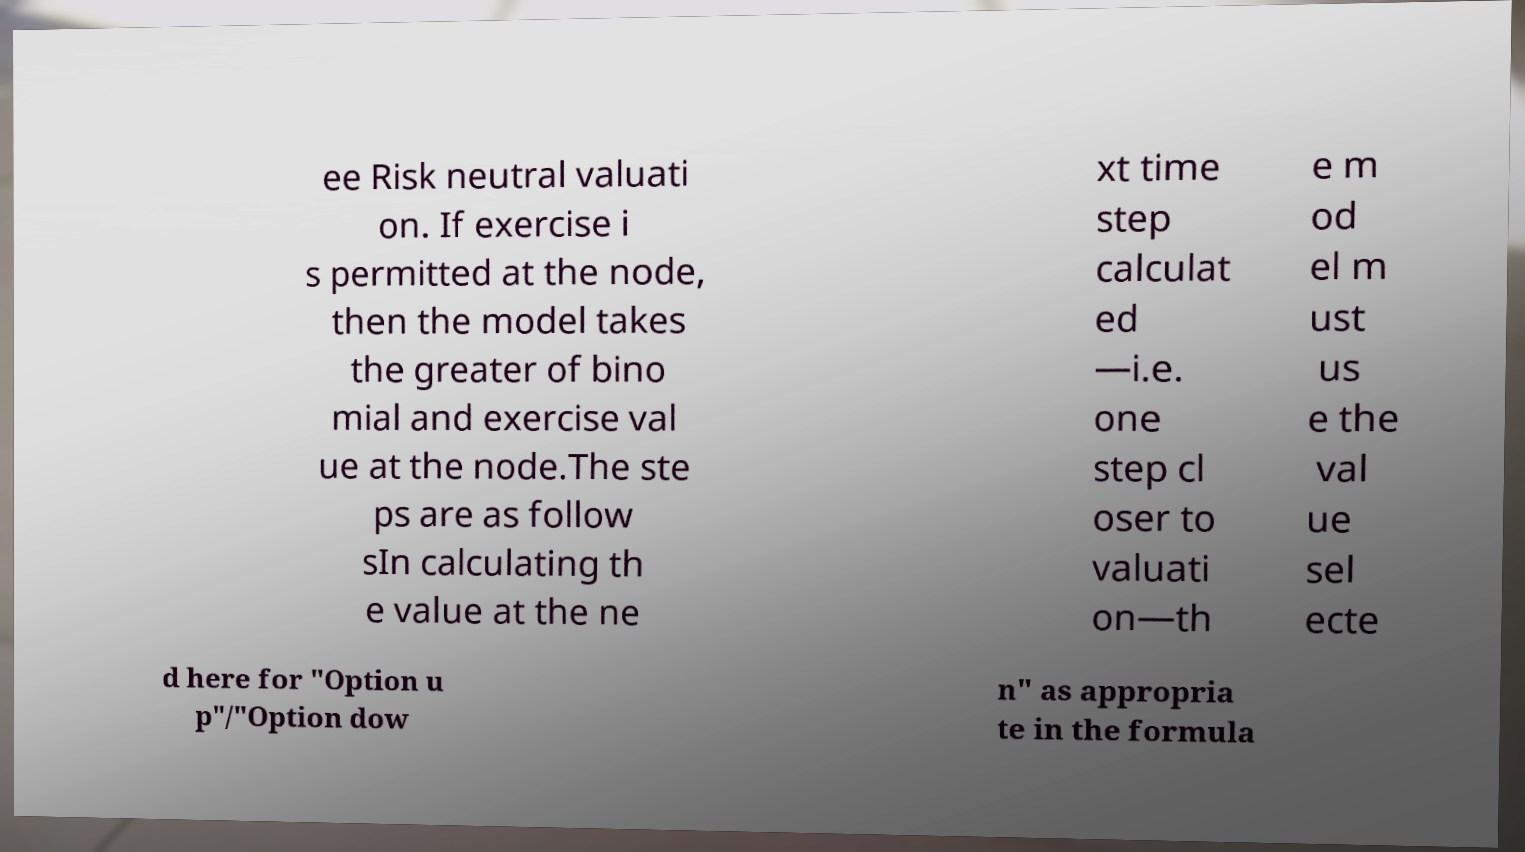Could you assist in decoding the text presented in this image and type it out clearly? ee Risk neutral valuati on. If exercise i s permitted at the node, then the model takes the greater of bino mial and exercise val ue at the node.The ste ps are as follow sIn calculating th e value at the ne xt time step calculat ed —i.e. one step cl oser to valuati on—th e m od el m ust us e the val ue sel ecte d here for "Option u p"/"Option dow n" as appropria te in the formula 